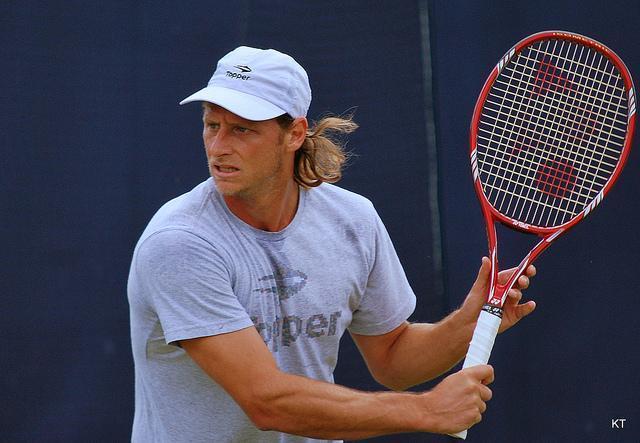How many red umbrellas do you see?
Give a very brief answer. 0. 